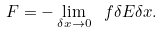<formula> <loc_0><loc_0><loc_500><loc_500>F = - \lim _ { \delta x \to 0 } \ f { \delta E } { \delta x } .</formula> 